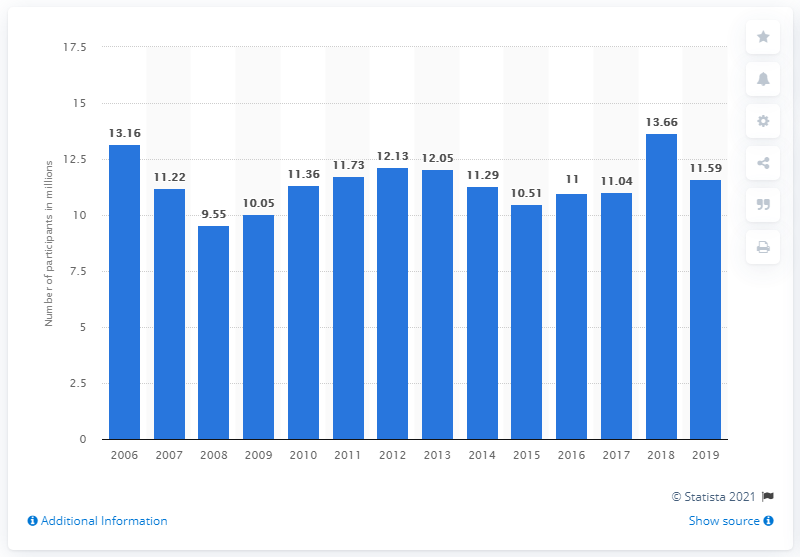Point out several critical features in this image. During the period of 2006 to 2019, there were approximately 11.59 million youth participants in running in the United States. 